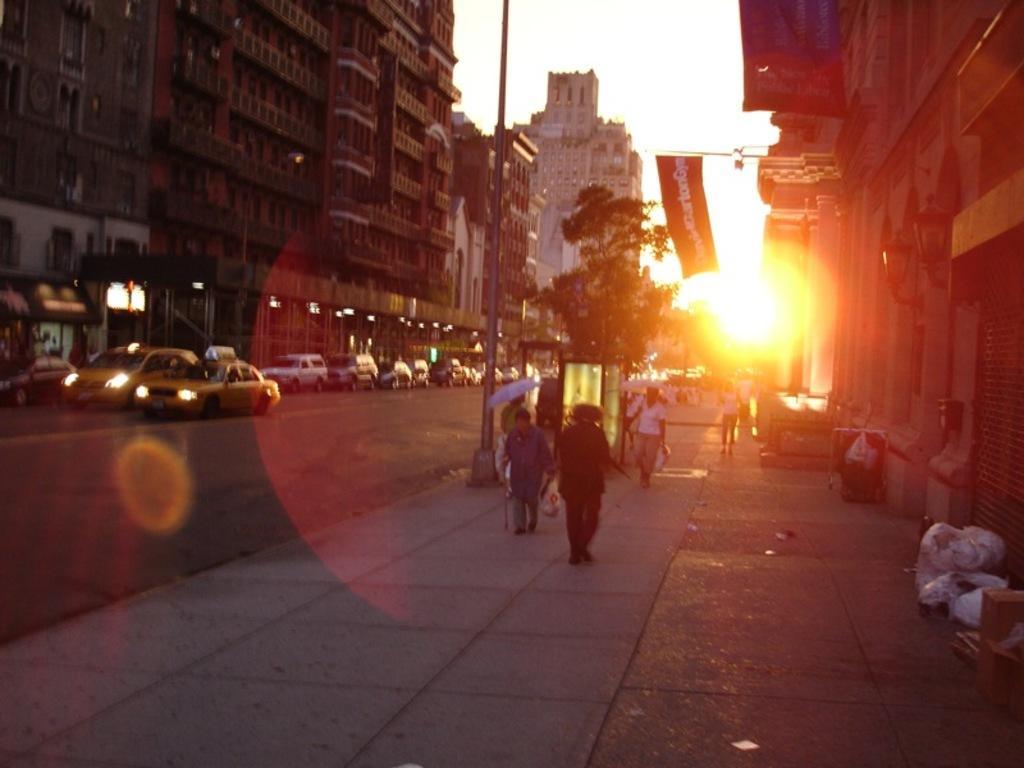Can you describe this image briefly? In this picture I can see buildings and few cars on the road and I can see few people walking on the sidewalk and I can see a human holding umbrella and I can see trees and a banner with some text and I can see sky. 